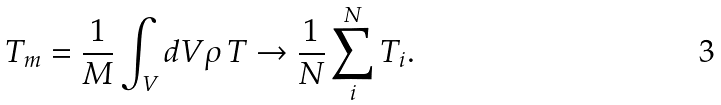<formula> <loc_0><loc_0><loc_500><loc_500>T _ { m } = \frac { 1 } { M } \int _ { V } d V \rho \, T \rightarrow \frac { 1 } { N } \sum _ { i } ^ { N } T _ { i } .</formula> 